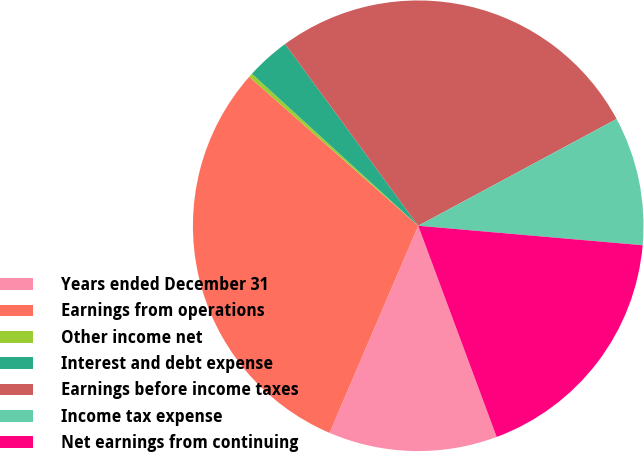Convert chart. <chart><loc_0><loc_0><loc_500><loc_500><pie_chart><fcel>Years ended December 31<fcel>Earnings from operations<fcel>Other income net<fcel>Interest and debt expense<fcel>Earnings before income taxes<fcel>Income tax expense<fcel>Net earnings from continuing<nl><fcel>12.1%<fcel>30.06%<fcel>0.29%<fcel>3.15%<fcel>27.2%<fcel>9.24%<fcel>17.96%<nl></chart> 